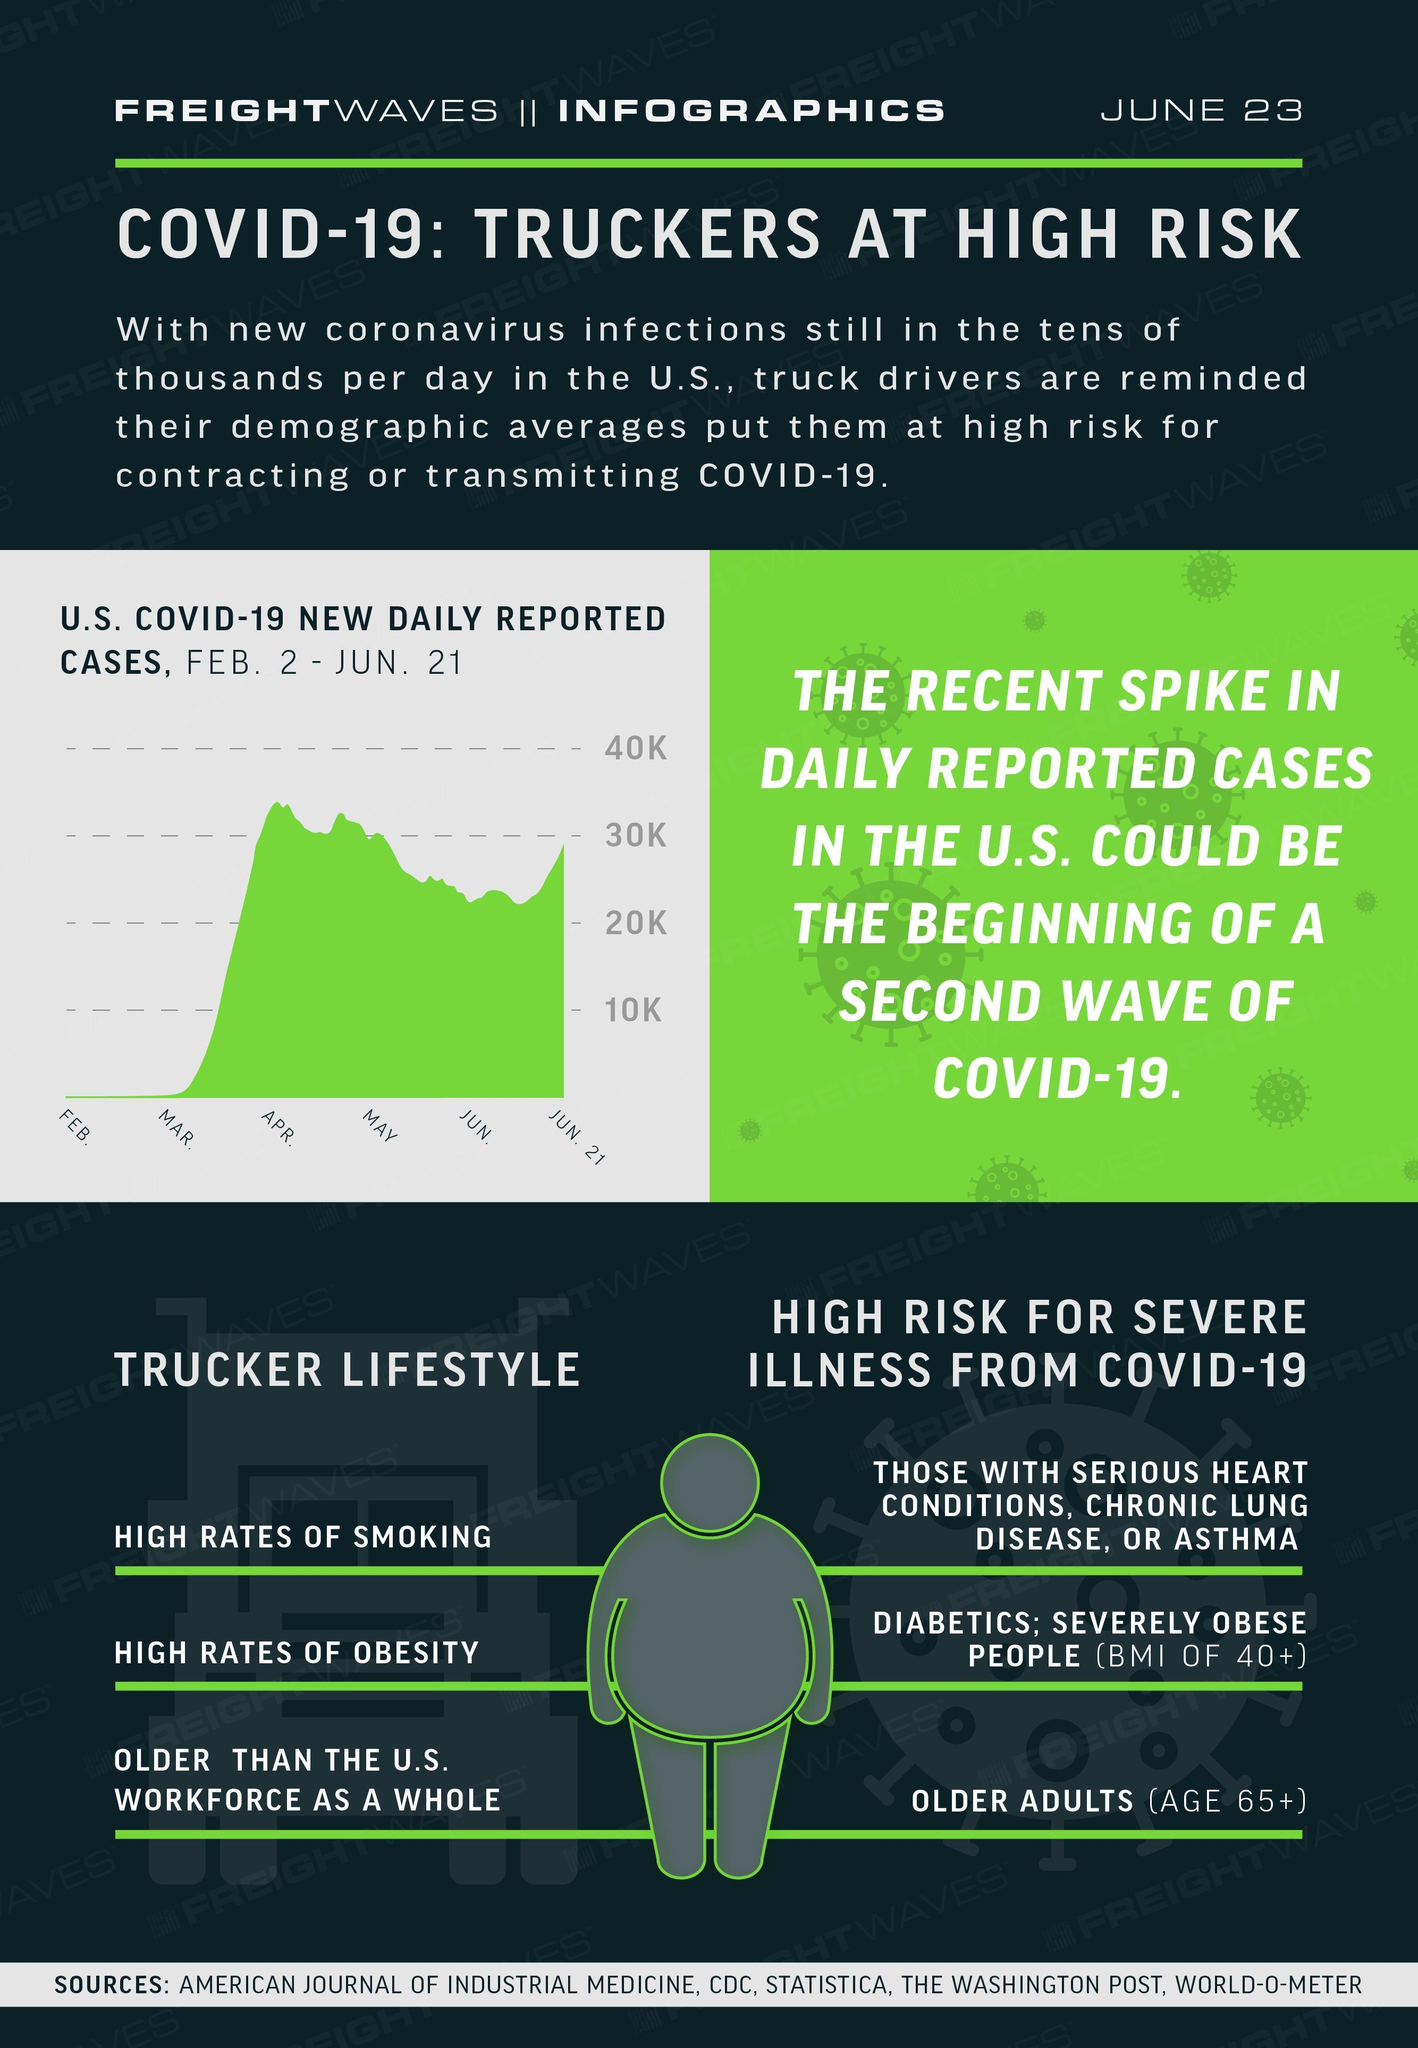Which lifestyles of a trucker show higher rates
Answer the question with a short phrase. smoking, obesity What high risk do older adults face severe illness from COVID-19 People with which disease face severe illness from COVID-19 those with serious heart conditions, chronic lung disease, or asthma 